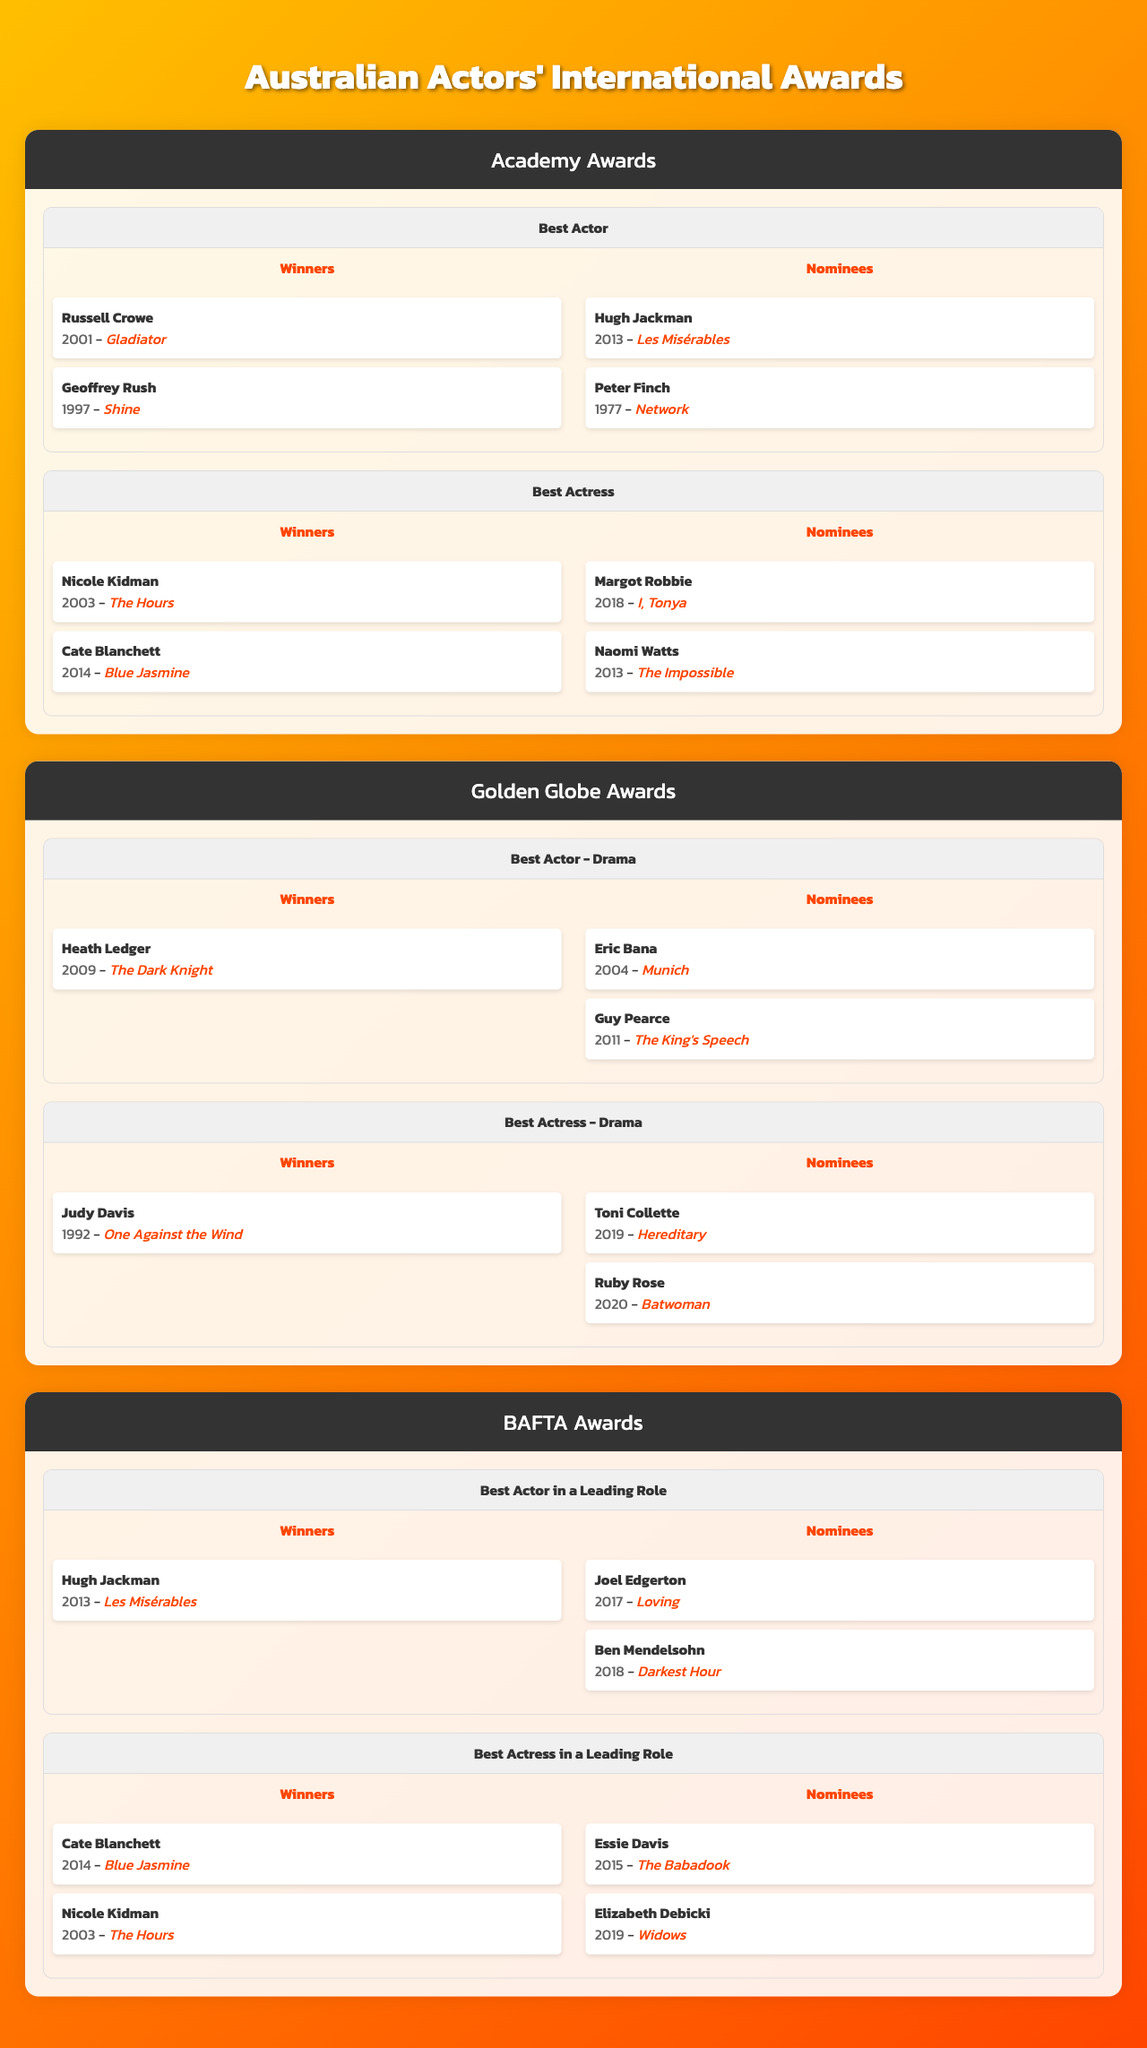What actors have won the Academy Award for Best Actor? The table indicates that Russell Crowe won for "Gladiator" in 2001 and Geoffrey Rush won for "Shine" in 1997.
Answer: Russell Crowe and Geoffrey Rush How many Australian actresses have won the Academy Award for Best Actress? According to the table, there are two winners: Nicole Kidman in 2003 and Cate Blanchett in 2014. Thus, the count is 2.
Answer: 2 Who was nominated for the Academy Award for Best Actor in 2013? The table lists Hugh Jackman as the nominee for Best Actor in 2013 for "Les Misérables."
Answer: Hugh Jackman Which Australian actress was nominated for a Golden Globe Award for Best Actress - Drama in 2019? The table shows that Toni Collette was nominated in 2019 for "Hereditary."
Answer: Toni Collette Have there been any winners from Australia at the Golden Globe Awards in the Best Actress - Drama category? Yes, Judy Davis won in 1992 for "One Against the Wind."
Answer: Yes How many Australian actors won the BAFTA Award for Best Actor in a Leading Role? The table mentions only Hugh Jackman as the winner in 2013, indicating there is 1 actor.
Answer: 1 Did any Australian actress win a BAFTA Award for Best Actress in a Leading Role in 2003? The table reveals that Nicole Kidman did win in 2003, confirming the statement is true.
Answer: Yes What is the total count of Australian nominees listed for the Academy Awards across all categories? There are two nominees in Best Actor and two in Best Actress categories, making it a total of 4 nominees.
Answer: 4 Which film did Heath Ledger win the Golden Globe Award for Best Actor - Drama? The table states that he won in 2009 for "The Dark Knight."
Answer: The Dark Knight Which Australian actor received nominations in both 2013 and 2018 at the Academy Awards? The only one noted is Hugh Jackman for Best Actor in 2013, while no other Australian actor is mentioned for 2018 in this category.
Answer: Hugh Jackman Which two Australian actresses won BAFTA Awards for Best Actress in a Leading Role? The winners listed in the table are Cate Blanchett in 2014 and Nicole Kidman in 2003.
Answer: Cate Blanchett and Nicole Kidman 